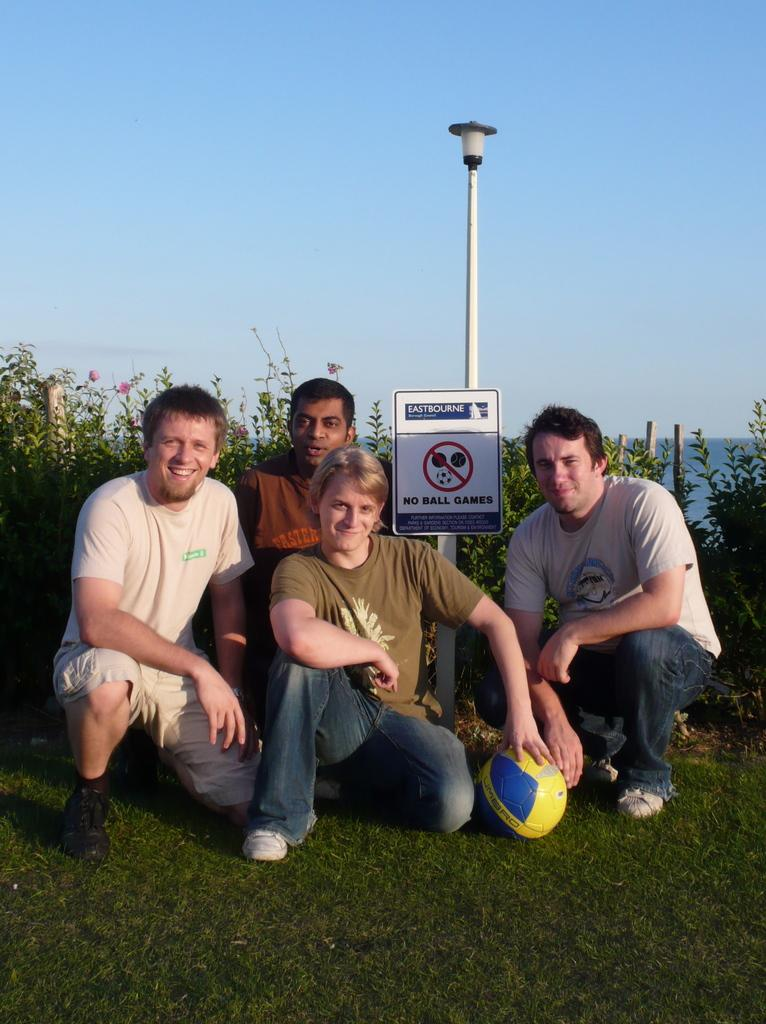What are the persons in the image doing? The persons in the image are on the ground. What is the surface they are standing on? The ground is covered in grass. What object can be seen in the image besides the persons and grass? There is a ball in the image. What other living organisms are present in the image? There are plants in the image. What structure can be seen in the image? There is a pole in the image. What is visible in the background of the image? The sky is visible in the background of the image. What letters are visible on the moon in the image? There is no moon visible in the image, and therefore no letters can be seen on it. 